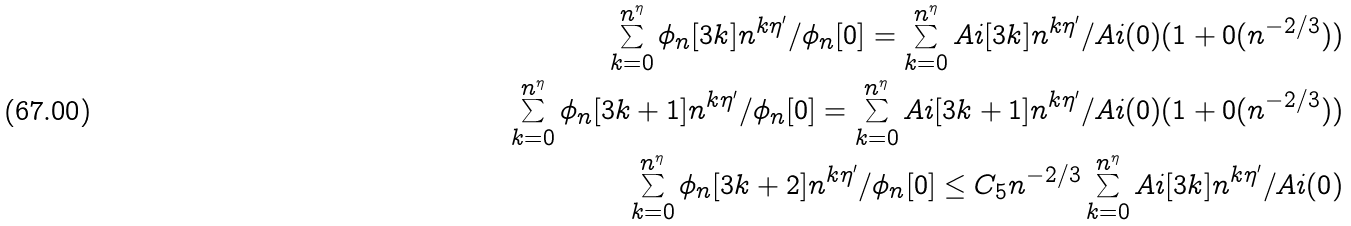Convert formula to latex. <formula><loc_0><loc_0><loc_500><loc_500>\sum _ { k = 0 } ^ { n ^ { \eta } } \phi _ { n } [ 3 k ] n ^ { k \eta ^ { \prime } } / \phi _ { n } [ 0 ] = \sum _ { k = 0 } ^ { n ^ { \eta } } A i [ 3 k ] n ^ { k \eta ^ { \prime } } / A i ( 0 ) ( 1 + 0 ( n ^ { - 2 / 3 } ) ) \\ \sum _ { k = 0 } ^ { n ^ { \eta } } \phi _ { n } [ 3 k + 1 ] n ^ { k \eta ^ { \prime } } / \phi _ { n } [ 0 ] = \sum _ { k = 0 } ^ { n ^ { \eta } } A i [ 3 k + 1 ] n ^ { k \eta ^ { \prime } } / A i ( 0 ) ( 1 + 0 ( n ^ { - 2 / 3 } ) ) \\ \sum _ { k = 0 } ^ { n ^ { \eta } } \phi _ { n } [ 3 k + 2 ] n ^ { k \eta ^ { \prime } } / \phi _ { n } [ 0 ] \leq C _ { 5 } n ^ { - 2 / 3 } \sum _ { k = 0 } ^ { n ^ { \eta } } A i [ 3 k ] n ^ { k \eta ^ { \prime } } / A i ( 0 )</formula> 